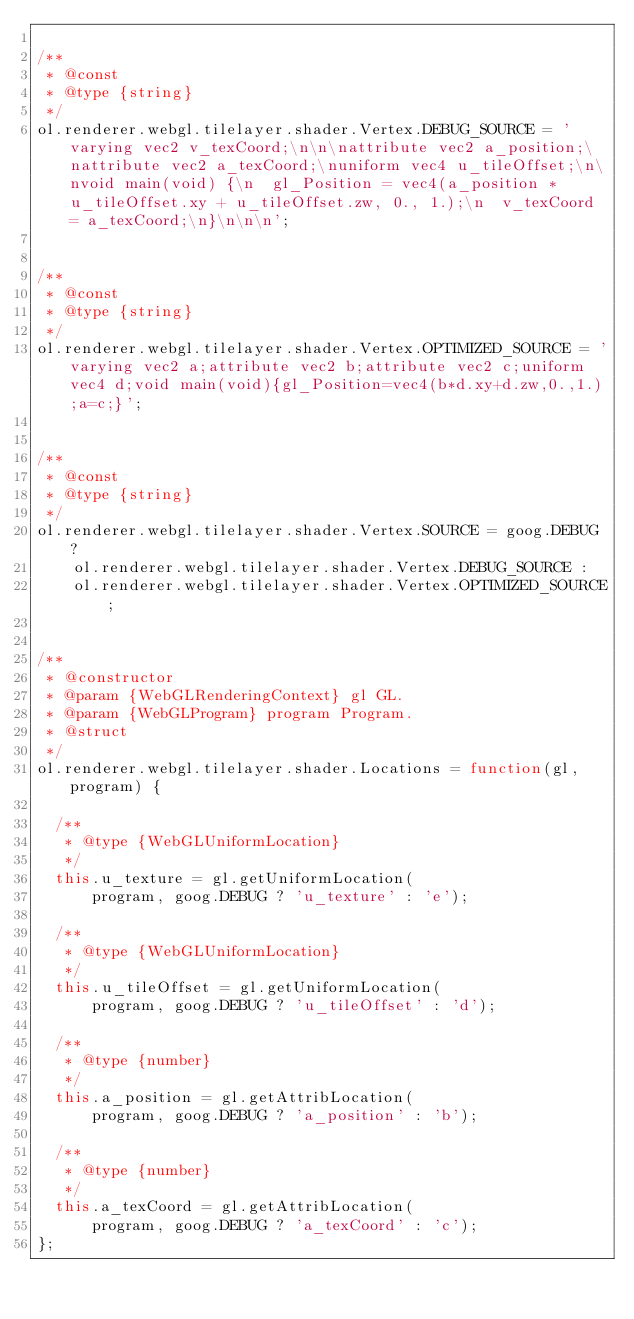Convert code to text. <code><loc_0><loc_0><loc_500><loc_500><_JavaScript_>
/**
 * @const
 * @type {string}
 */
ol.renderer.webgl.tilelayer.shader.Vertex.DEBUG_SOURCE = 'varying vec2 v_texCoord;\n\n\nattribute vec2 a_position;\nattribute vec2 a_texCoord;\nuniform vec4 u_tileOffset;\n\nvoid main(void) {\n  gl_Position = vec4(a_position * u_tileOffset.xy + u_tileOffset.zw, 0., 1.);\n  v_texCoord = a_texCoord;\n}\n\n\n';


/**
 * @const
 * @type {string}
 */
ol.renderer.webgl.tilelayer.shader.Vertex.OPTIMIZED_SOURCE = 'varying vec2 a;attribute vec2 b;attribute vec2 c;uniform vec4 d;void main(void){gl_Position=vec4(b*d.xy+d.zw,0.,1.);a=c;}';


/**
 * @const
 * @type {string}
 */
ol.renderer.webgl.tilelayer.shader.Vertex.SOURCE = goog.DEBUG ?
    ol.renderer.webgl.tilelayer.shader.Vertex.DEBUG_SOURCE :
    ol.renderer.webgl.tilelayer.shader.Vertex.OPTIMIZED_SOURCE;


/**
 * @constructor
 * @param {WebGLRenderingContext} gl GL.
 * @param {WebGLProgram} program Program.
 * @struct
 */
ol.renderer.webgl.tilelayer.shader.Locations = function(gl, program) {

  /**
   * @type {WebGLUniformLocation}
   */
  this.u_texture = gl.getUniformLocation(
      program, goog.DEBUG ? 'u_texture' : 'e');

  /**
   * @type {WebGLUniformLocation}
   */
  this.u_tileOffset = gl.getUniformLocation(
      program, goog.DEBUG ? 'u_tileOffset' : 'd');

  /**
   * @type {number}
   */
  this.a_position = gl.getAttribLocation(
      program, goog.DEBUG ? 'a_position' : 'b');

  /**
   * @type {number}
   */
  this.a_texCoord = gl.getAttribLocation(
      program, goog.DEBUG ? 'a_texCoord' : 'c');
};
</code> 